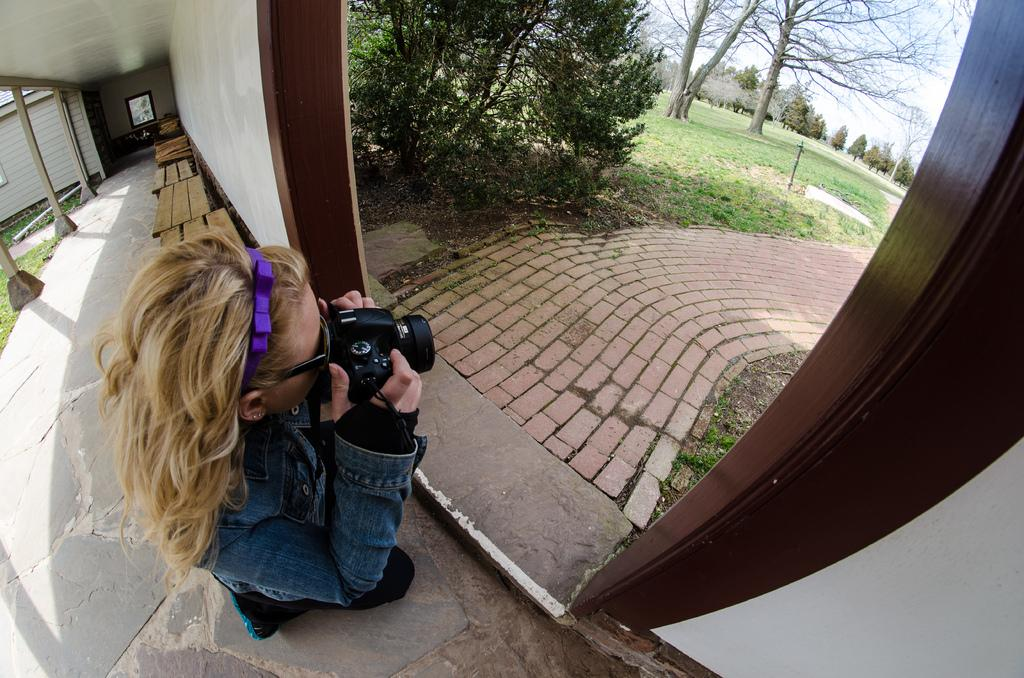Who is the main subject in the image? There is a girl in the image. What is the girl holding in the image? The girl is holding a camera. What is the girl doing with the camera? The girl is taking a picture of trees. What type of seating is present in the scene? There are benches in the scene. Can you hear the sound of a bell in the image? There is no sound present in the image, as it is a still photograph. What type of worm can be seen crawling on the girl's camera in the image? There are no worms present in the image, and the girl's camera is not being crawled on by any creature. 